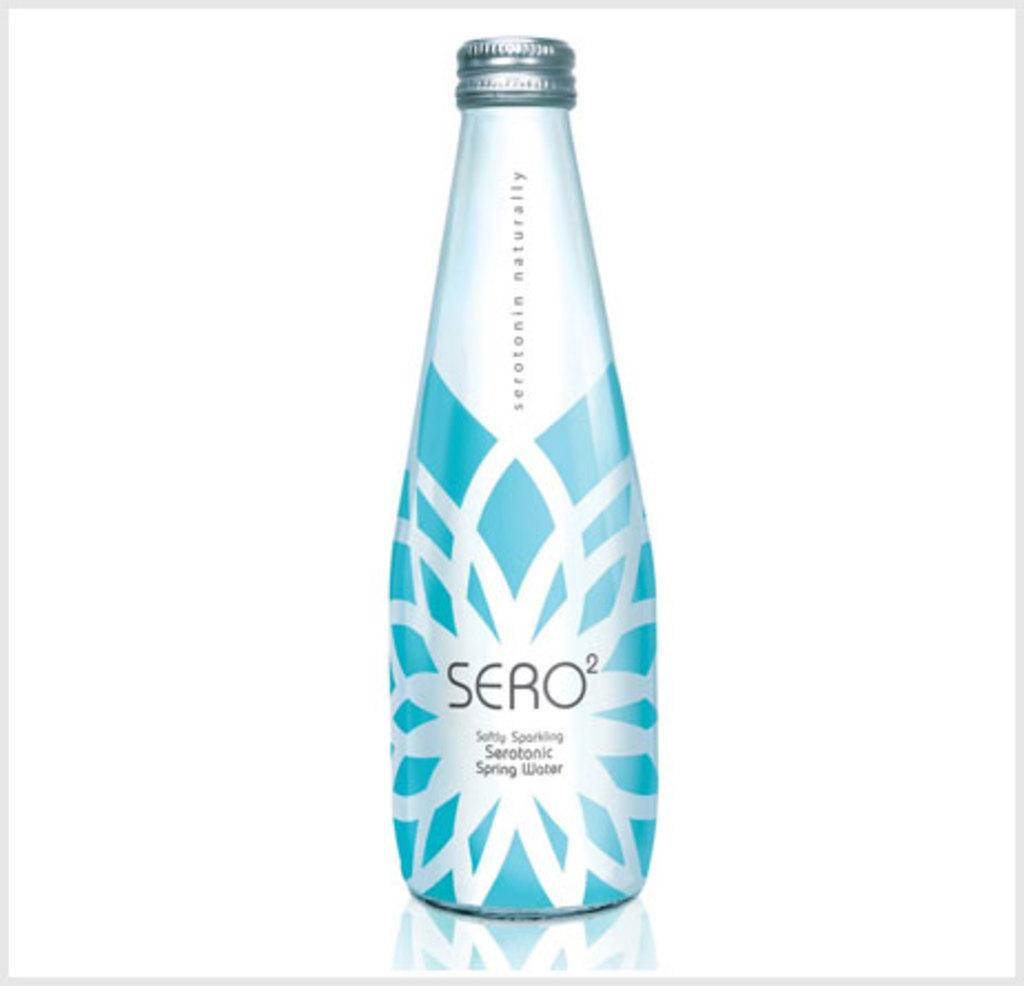<image>
Describe the image concisely. A blue bottle of Sero2 Spring Water on a white background. 